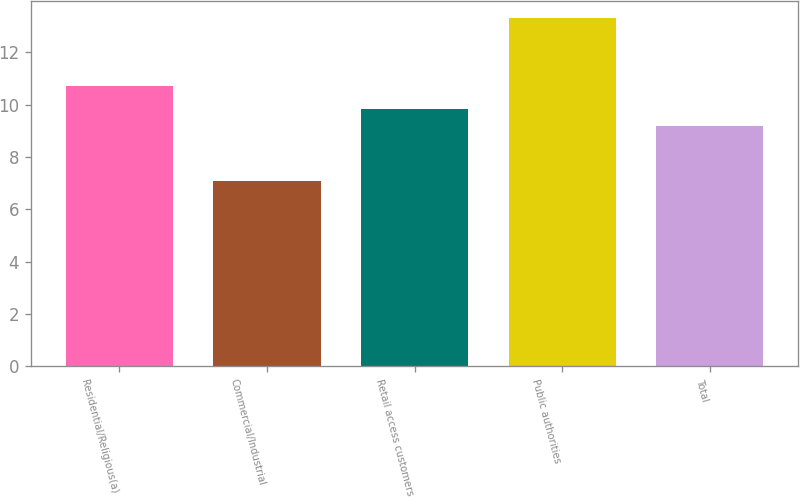<chart> <loc_0><loc_0><loc_500><loc_500><bar_chart><fcel>Residential/Religious(a)<fcel>Commercial/Industrial<fcel>Retail access customers<fcel>Public authorities<fcel>Total<nl><fcel>10.7<fcel>7.1<fcel>9.82<fcel>13.3<fcel>9.2<nl></chart> 